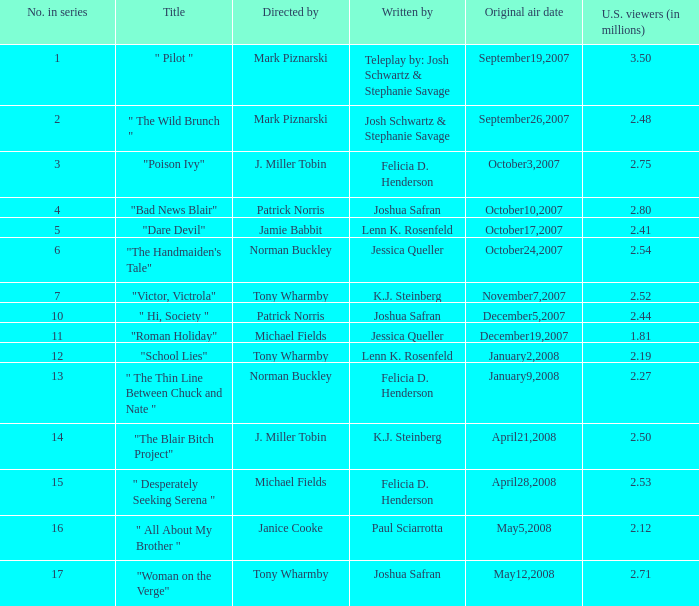Parse the full table. {'header': ['No. in series', 'Title', 'Directed by', 'Written by', 'Original air date', 'U.S. viewers (in millions)'], 'rows': [['1', '" Pilot "', 'Mark Piznarski', 'Teleplay by: Josh Schwartz & Stephanie Savage', 'September19,2007', '3.50'], ['2', '" The Wild Brunch "', 'Mark Piznarski', 'Josh Schwartz & Stephanie Savage', 'September26,2007', '2.48'], ['3', '"Poison Ivy"', 'J. Miller Tobin', 'Felicia D. Henderson', 'October3,2007', '2.75'], ['4', '"Bad News Blair"', 'Patrick Norris', 'Joshua Safran', 'October10,2007', '2.80'], ['5', '"Dare Devil"', 'Jamie Babbit', 'Lenn K. Rosenfeld', 'October17,2007', '2.41'], ['6', '"The Handmaiden\'s Tale"', 'Norman Buckley', 'Jessica Queller', 'October24,2007', '2.54'], ['7', '"Victor, Victrola"', 'Tony Wharmby', 'K.J. Steinberg', 'November7,2007', '2.52'], ['10', '" Hi, Society "', 'Patrick Norris', 'Joshua Safran', 'December5,2007', '2.44'], ['11', '"Roman Holiday"', 'Michael Fields', 'Jessica Queller', 'December19,2007', '1.81'], ['12', '"School Lies"', 'Tony Wharmby', 'Lenn K. Rosenfeld', 'January2,2008', '2.19'], ['13', '" The Thin Line Between Chuck and Nate "', 'Norman Buckley', 'Felicia D. Henderson', 'January9,2008', '2.27'], ['14', '"The Blair Bitch Project"', 'J. Miller Tobin', 'K.J. Steinberg', 'April21,2008', '2.50'], ['15', '" Desperately Seeking Serena "', 'Michael Fields', 'Felicia D. Henderson', 'April28,2008', '2.53'], ['16', '" All About My Brother "', 'Janice Cooke', 'Paul Sciarrotta', 'May5,2008', '2.12'], ['17', '"Woman on the Verge"', 'Tony Wharmby', 'Joshua Safran', 'May12,2008', '2.71']]} How many u.s. audience members (in millions) have "dare devil" as the title? 2.41. 